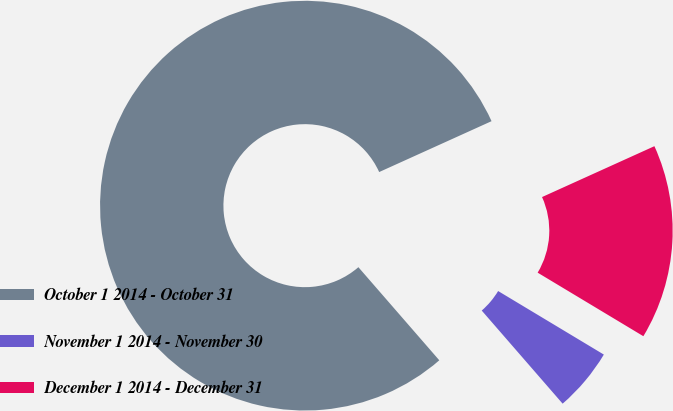<chart> <loc_0><loc_0><loc_500><loc_500><pie_chart><fcel>October 1 2014 - October 31<fcel>November 1 2014 - November 30<fcel>December 1 2014 - December 31<nl><fcel>79.62%<fcel>5.0%<fcel>15.38%<nl></chart> 